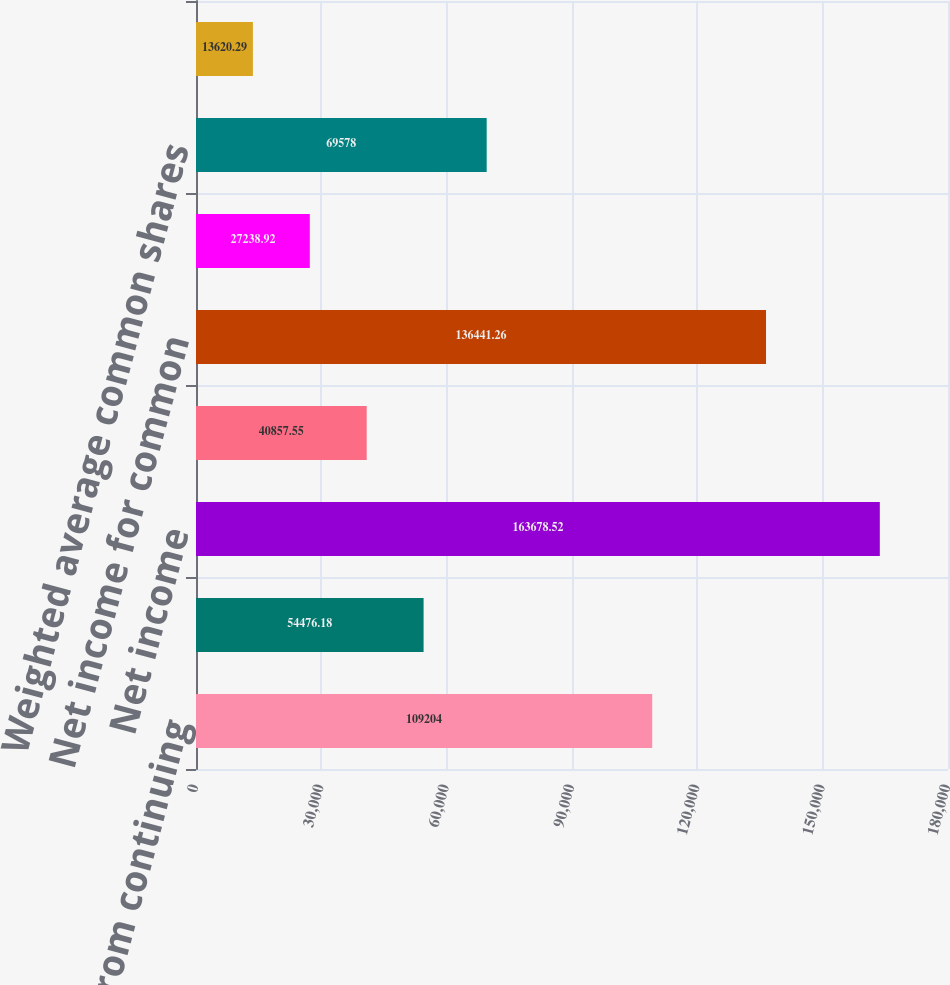Convert chart to OTSL. <chart><loc_0><loc_0><loc_500><loc_500><bar_chart><fcel>Income from continuing<fcel>Discontinued operations<fcel>Net income<fcel>Less Preferred stock dividends<fcel>Net income for common<fcel>Less Dividends paid on<fcel>Weighted average common shares<fcel>Incremental shares to be<nl><fcel>109204<fcel>54476.2<fcel>163679<fcel>40857.6<fcel>136441<fcel>27238.9<fcel>69578<fcel>13620.3<nl></chart> 